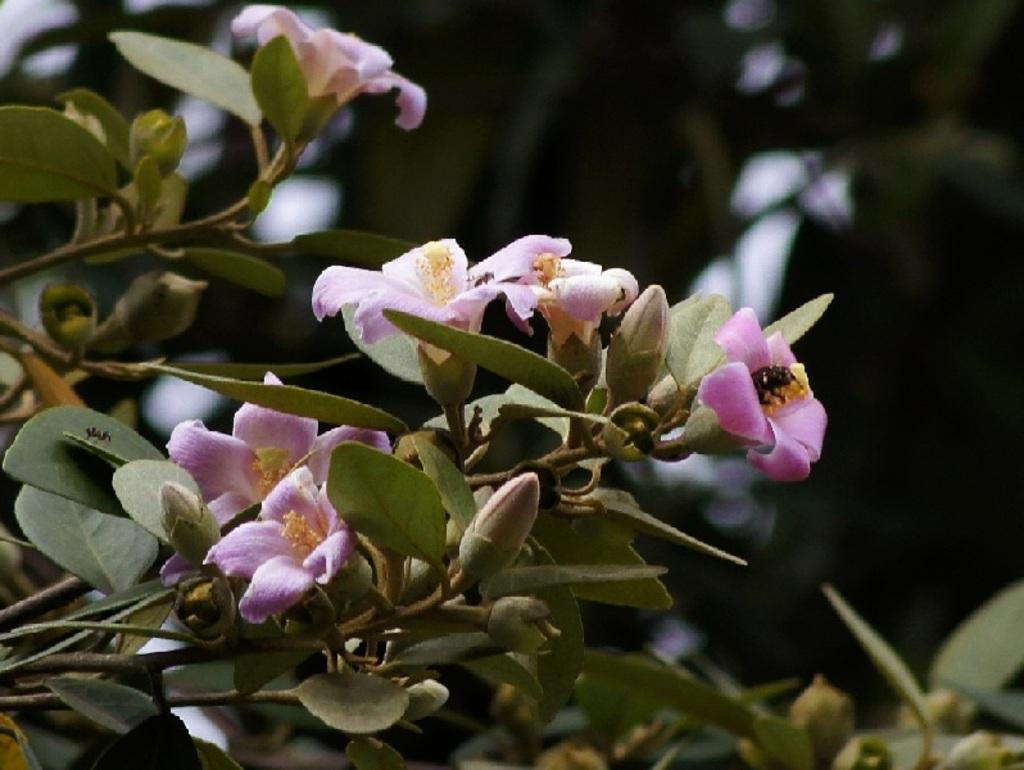What type of plant is visible in the image? There is a plant with flowers in the image. Can you describe the background of the image? The background of the image is blurry. How does the plant express regret in the image? Plants do not have the ability to express regret, as they are not sentient beings. 